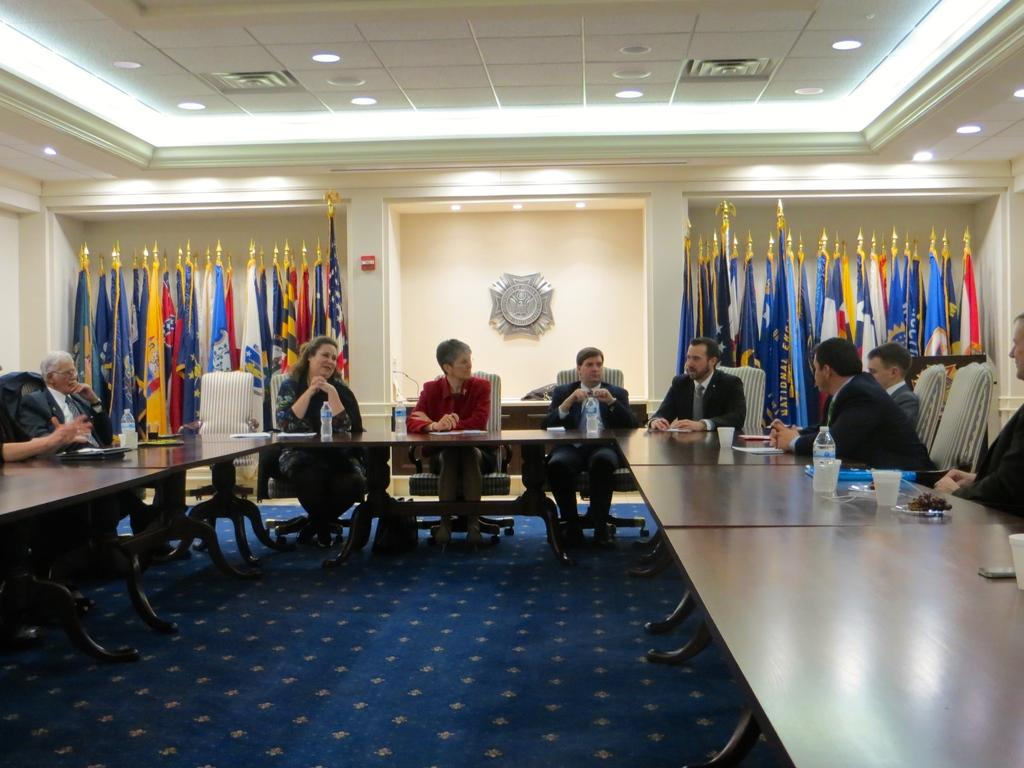What are the people in the image doing? The people in the image are sitting on chairs. What can be seen on the table in the image? There is a water bottle and a glass on the table. What is visible in the image that represents a symbol or country? There are flags visible in the image. What is in the background of the image? There is a wall in the background of the image. What type of club is being used in the image? There is no club present in the image. What curve can be seen in the image? There is no curve that stands out in the image. 